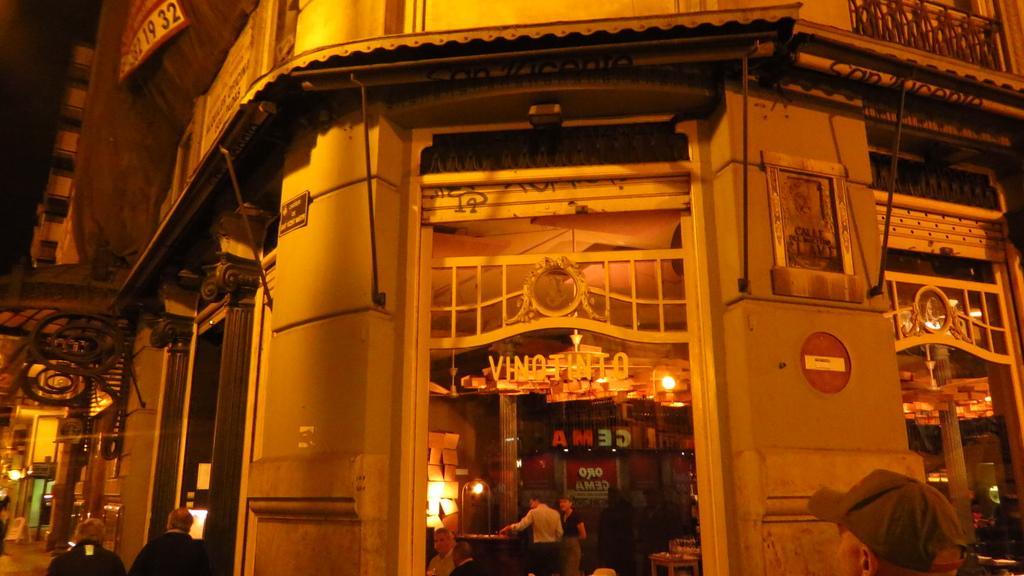In one or two sentences, can you explain what this image depicts? In this image there are a few buildings and few people on the road. 